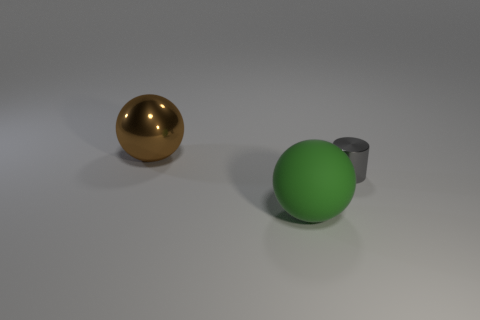Add 3 small metal cylinders. How many objects exist? 6 Subtract all balls. How many objects are left? 1 Subtract 0 yellow cylinders. How many objects are left? 3 Subtract all big green objects. Subtract all cylinders. How many objects are left? 1 Add 1 large brown metallic balls. How many large brown metallic balls are left? 2 Add 1 metal cylinders. How many metal cylinders exist? 2 